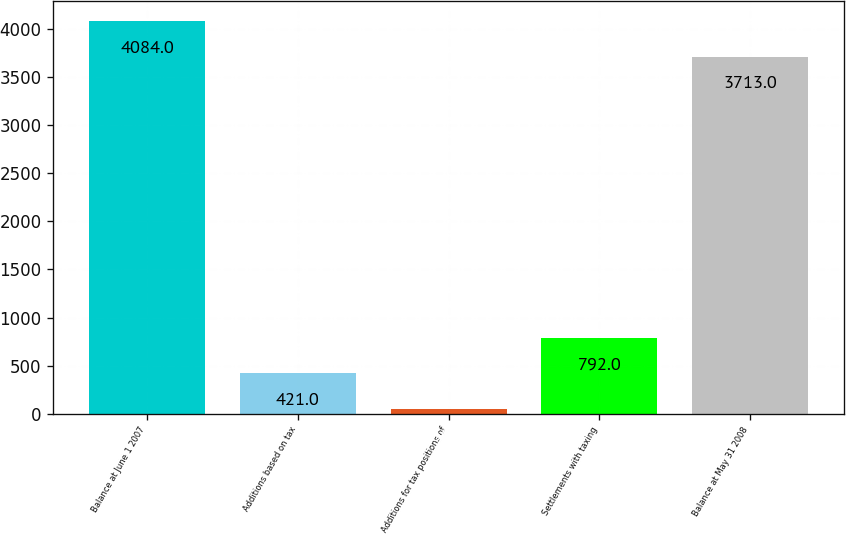Convert chart to OTSL. <chart><loc_0><loc_0><loc_500><loc_500><bar_chart><fcel>Balance at June 1 2007<fcel>Additions based on tax<fcel>Additions for tax positions of<fcel>Settlements with taxing<fcel>Balance at May 31 2008<nl><fcel>4084<fcel>421<fcel>50<fcel>792<fcel>3713<nl></chart> 